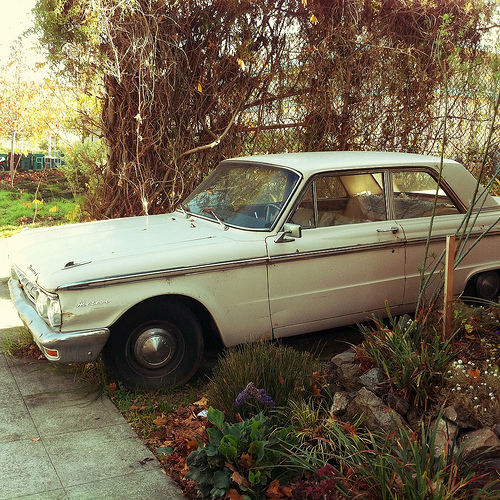<image>
Is there a tire on the plant? No. The tire is not positioned on the plant. They may be near each other, but the tire is not supported by or resting on top of the plant. 